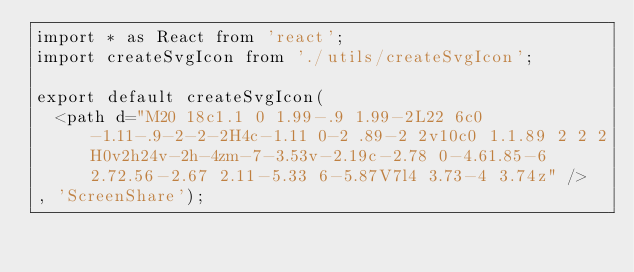Convert code to text. <code><loc_0><loc_0><loc_500><loc_500><_JavaScript_>import * as React from 'react';
import createSvgIcon from './utils/createSvgIcon';

export default createSvgIcon(
  <path d="M20 18c1.1 0 1.99-.9 1.99-2L22 6c0-1.11-.9-2-2-2H4c-1.11 0-2 .89-2 2v10c0 1.1.89 2 2 2H0v2h24v-2h-4zm-7-3.53v-2.19c-2.78 0-4.61.85-6 2.72.56-2.67 2.11-5.33 6-5.87V7l4 3.73-4 3.74z" />
, 'ScreenShare');
</code> 